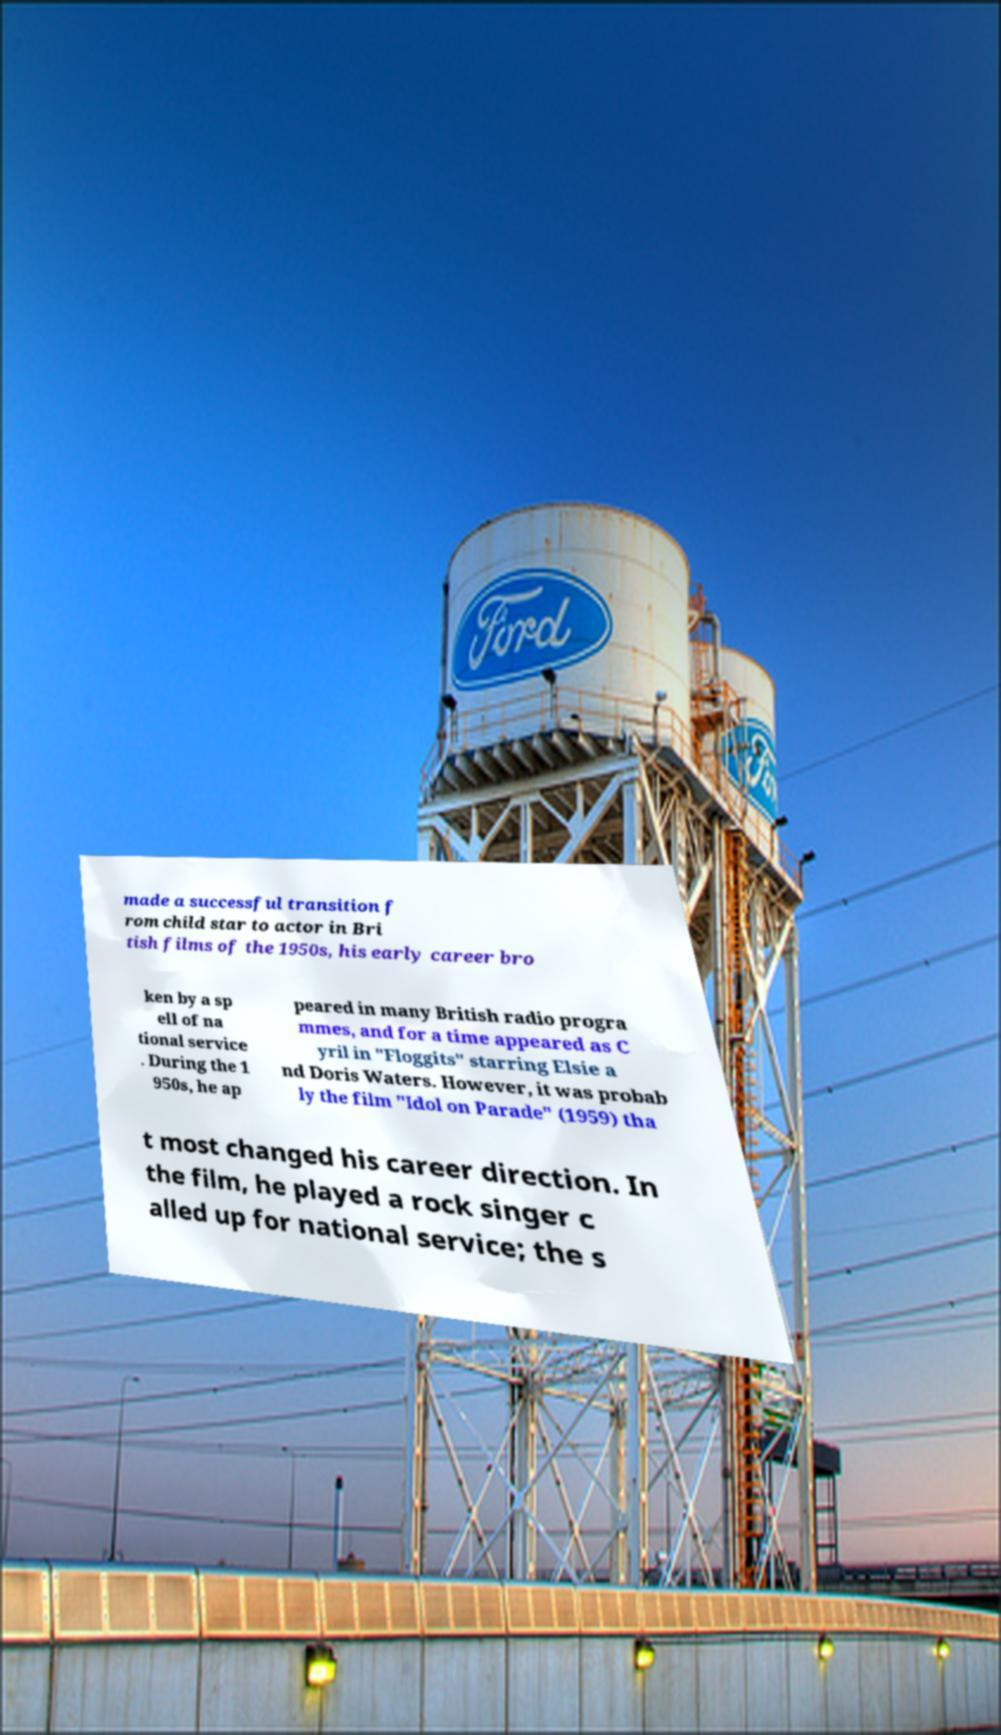Can you read and provide the text displayed in the image?This photo seems to have some interesting text. Can you extract and type it out for me? made a successful transition f rom child star to actor in Bri tish films of the 1950s, his early career bro ken by a sp ell of na tional service . During the 1 950s, he ap peared in many British radio progra mmes, and for a time appeared as C yril in "Floggits" starring Elsie a nd Doris Waters. However, it was probab ly the film "Idol on Parade" (1959) tha t most changed his career direction. In the film, he played a rock singer c alled up for national service; the s 